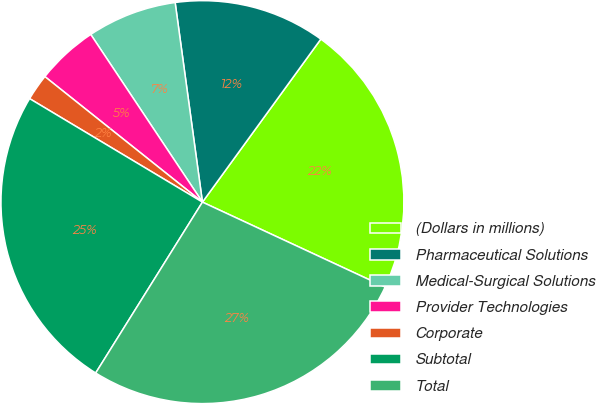Convert chart to OTSL. <chart><loc_0><loc_0><loc_500><loc_500><pie_chart><fcel>(Dollars in millions)<fcel>Pharmaceutical Solutions<fcel>Medical-Surgical Solutions<fcel>Provider Technologies<fcel>Corporate<fcel>Subtotal<fcel>Total<nl><fcel>21.93%<fcel>12.16%<fcel>7.19%<fcel>4.94%<fcel>2.12%<fcel>24.7%<fcel>26.96%<nl></chart> 